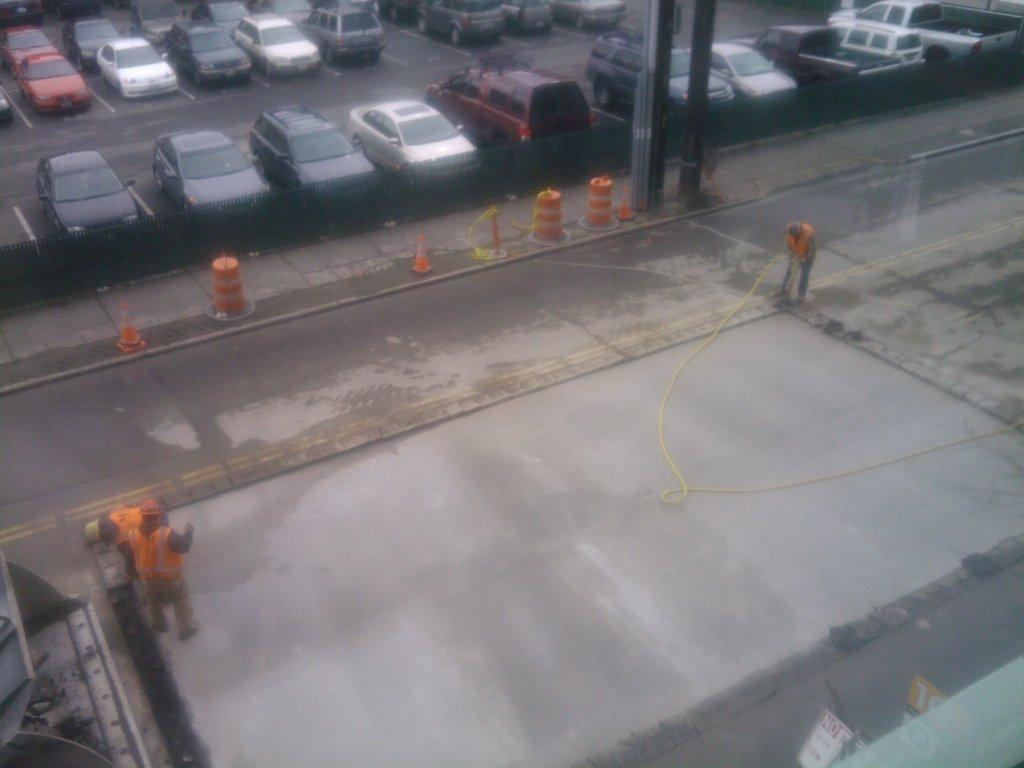What type of object is located at the bottom of the image? There is a metal object at the bottom of the image. What can be seen on the sides of the road in the image? There are hoardings, poles, and plants on the road in the image. What is present on the road in the image? There are people, plants, poles, and vehicles on the road in the image. Can you describe the pipe in the image? There is a pipe in the image, but no additional details are provided about its appearance or function. What type of fruit is being sold at the hoarding in the image? There is no fruit being sold at the hoarding in the image; it is a sign or advertisement. Can you tell me the order in which the people are standing on the road in the image? The provided facts do not give enough information to determine the order in which the people are standing on the road. Is there a basketball court visible in the image? There is no mention of a basketball court or any basketball-related objects in the image. 